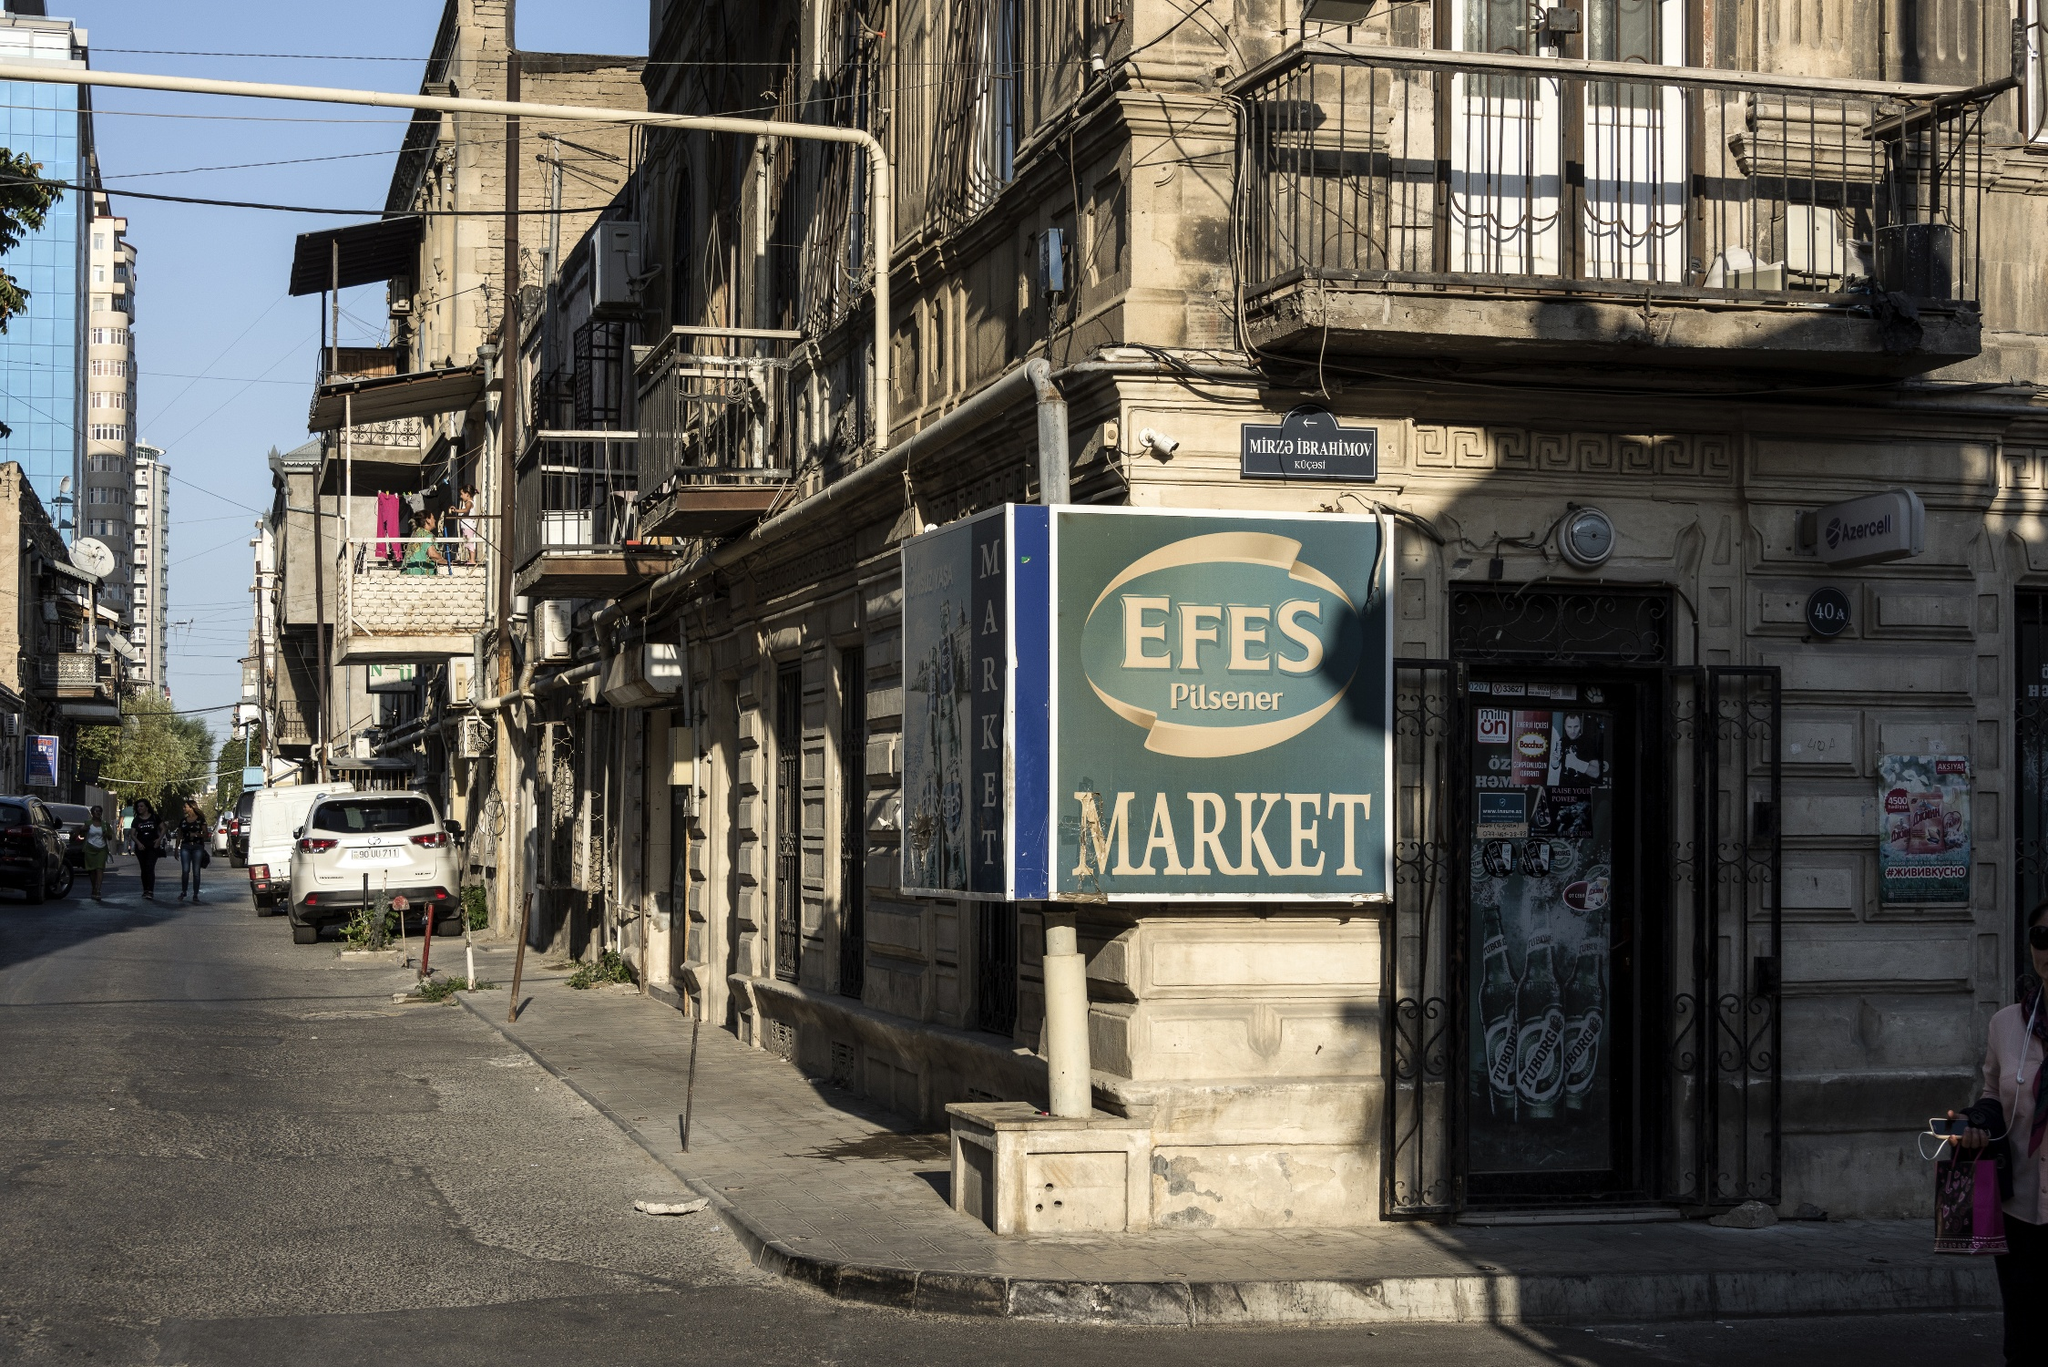What does the surrounding architecture tell you about the area? The surrounding architecture, with its weathered facades, iron balconies, and tall, narrow windows, tells a story of an older, historically rich neighborhood in Istanbul, Turkey. The buildings showcase a blend of classic European influences with Middle Eastern architectural elements, reflecting the city's diverse cultural heritage. The intricate ironwork on the balconies suggests a craft that has been passed down through generations. The presence of small markets and residential features hints at a mixed-use area where daily life unfolds amidst historical surroundings. 